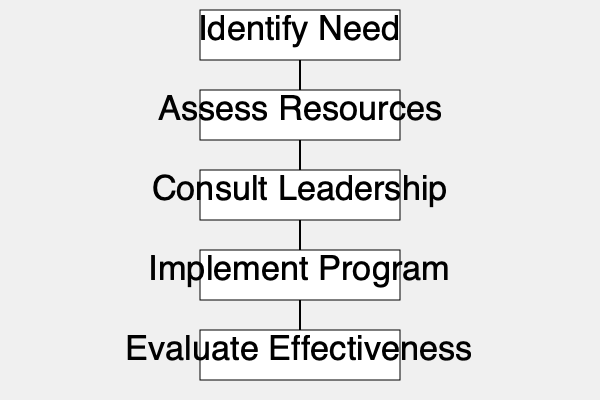In the flowchart depicting the decision-making process for implementing new church programs, which step immediately follows "Assess Resources"? To answer this question, we need to follow the flowchart from top to bottom:

1. The process begins with "Identify Need" at the top of the flowchart.
2. An arrow leads down to "Assess Resources," which is the second step in the process.
3. Following "Assess Resources," there is another arrow pointing downward.
4. This arrow leads to the next step, which is "Consult Leadership."
5. After "Consult Leadership," the flowchart continues with "Implement Program" and finally "Evaluate Effectiveness."

Therefore, the step that immediately follows "Assess Resources" in this decision-making process is "Consult Leadership."
Answer: Consult Leadership 